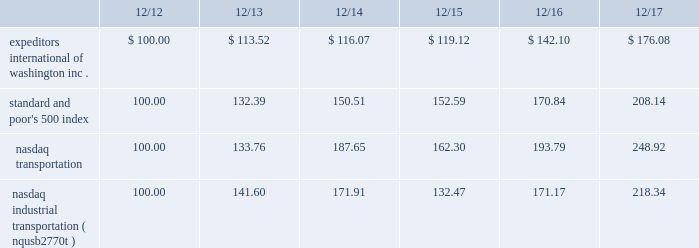The graph below compares expeditors international of washington , inc.'s cumulative 5-year total shareholder return on common stock with the cumulative total returns of the s&p 500 index , the nasdaq transportation index , and the nasdaq industrial transportation index ( nqusb2770t ) as a replacement for the nasdaq transportation index .
The company is making the modification to reference a specific transportation index and to source that data directly from nasdaq .
The graph assumes that the value of the investment in our common stock and in each of the indexes ( including reinvestment of dividends ) was $ 100 on 12/31/2012 and tracks it through 12/31/2017 .
Total return assumes reinvestment of dividends in each of the indices indicated .
Comparison of 5-year cumulative total return among expeditors international of washington , inc. , the s&p 500 index , the nasdaq industrial transportation index and the nasdaq transportation index. .
The stock price performance included in this graph is not necessarily indicative of future stock price performance .
Item 6 2014 selected financial data financial highlights in thousands , except per share data 2017 2016 2015 2014 2013 revenues ..................................................................... .
$ 6920948 6098037 6616632 6564721 6080257 net revenues1 ............................................................... .
$ 2319189 2164036 2187777 1981427 1882853 net earnings attributable to shareholders ..................... .
$ 489345 430807 457223 376888 348526 diluted earnings attributable to shareholders per share $ 2.69 2.36 2.40 1.92 1.68 basic earnings attributable to shareholders per share.. .
$ 2.73 2.38 2.42 1.92 1.69 dividends declared and paid per common share.......... .
$ 0.84 0.80 0.72 0.64 0.60 cash used for dividends ............................................... .
$ 150495 145123 135673 124634 123292 cash used for share repurchases ................................. .
$ 478258 337658 629991 550781 261936 working capital ............................................................. .
$ 1448333 1288648 1115136 1285188 1526673 total assets .................................................................. .
$ 3117008 2790871 2565577 2870626 2996416 shareholders 2019 equity ..................................................... .
$ 1991858 1844638 1691993 1868408 2084783 weighted average diluted shares outstanding .............. .
181666 182704 190223 196768 206895 weighted average basic shares outstanding ................ .
179247 181282 188941 196147 205995 _______________________ 1non-gaap measure calculated as revenues less directly related operating expenses attributable to our principal services .
See management's discussion and analysis for a reconciliation of net revenues to revenues .
Safe harbor for forward-looking statements under private securities litigation reform act of 1995 ; certain cautionary statements this annual report on form 10-k for the fiscal year ended december 31 , 2017 contains 201cforward-looking statements , 201d as defined in section 27a of the securities act of 1933 , as amended , and section 21e of the securities exchange act of 1934 , as amended .
From time to time , expeditors or its representatives have made or may make forward-looking statements , orally or in writing .
Such forward-looking statements may be included in , but not limited to , press releases , presentations , oral statements made with the approval of an authorized executive officer or in various filings made by expeditors with the securities and exchange commission .
Statements including those preceded by , followed by or that include the words or phrases 201cwill likely result 201d , 201care expected to 201d , "would expect" , "would not expect" , 201cwill continue 201d , 201cis anticipated 201d , 201cestimate 201d , 201cproject 201d , "provisional" , "plan" , "believe" , "probable" , "reasonably possible" , "may" , "could" , "should" , "intends" , "foreseeable future" or similar expressions are intended to identify 201cforward-looking statements 201d within the meaning of the private securities litigation reform act of 1995 .
Such statements are qualified in their entirety by reference to and are accompanied by the discussion in item 1a of certain important factors that could cause actual results to differ materially from such forward-looking statements .
The risks included in item 1a are not exhaustive .
Furthermore , reference is also made to other sections of this report , which include additional factors that could adversely impact expeditors' business and financial performance .
Moreover , expeditors operates in a very competitive , complex and rapidly changing global environment .
New risk factors emerge from time to time and it is not possible for management to predict all of such risk factors , nor can it assess the impact of all of such risk factors on expeditors' business or the extent to which any factor , or combination of factors , may cause actual results to differ materially from those contained in any forward-looking statements .
Accordingly , forward-looking statements cannot be relied upon as a guarantee of actual results .
Shareholders should be aware that while expeditors does , from time to time , communicate with securities analysts , it is against expeditors' policy to disclose to such analysts any material non-public information or other confidential commercial information .
Accordingly , shareholders should not assume that expeditors agrees with any statement or report issued by any analyst irrespective of the content of such statement or report .
Furthermore , expeditors has a policy against issuing financial forecasts or projections or confirming the accuracy of forecasts or projections issued by others .
Accordingly , to the extent that reports issued by securities analysts contain any projections , forecasts or opinions , such reports are not the responsibility of expeditors. .
What is the difference in percentage return between expeditors international of washington inc . and the nasdaq transportation for the five years ended 12/17? 
Computations: (((176.08 - 100) / 100) - ((248.92 - 100) / 100))
Answer: -0.7284. The graph below compares expeditors international of washington , inc.'s cumulative 5-year total shareholder return on common stock with the cumulative total returns of the s&p 500 index , the nasdaq transportation index , and the nasdaq industrial transportation index ( nqusb2770t ) as a replacement for the nasdaq transportation index .
The company is making the modification to reference a specific transportation index and to source that data directly from nasdaq .
The graph assumes that the value of the investment in our common stock and in each of the indexes ( including reinvestment of dividends ) was $ 100 on 12/31/2012 and tracks it through 12/31/2017 .
Total return assumes reinvestment of dividends in each of the indices indicated .
Comparison of 5-year cumulative total return among expeditors international of washington , inc. , the s&p 500 index , the nasdaq industrial transportation index and the nasdaq transportation index. .
The stock price performance included in this graph is not necessarily indicative of future stock price performance .
Item 6 2014 selected financial data financial highlights in thousands , except per share data 2017 2016 2015 2014 2013 revenues ..................................................................... .
$ 6920948 6098037 6616632 6564721 6080257 net revenues1 ............................................................... .
$ 2319189 2164036 2187777 1981427 1882853 net earnings attributable to shareholders ..................... .
$ 489345 430807 457223 376888 348526 diluted earnings attributable to shareholders per share $ 2.69 2.36 2.40 1.92 1.68 basic earnings attributable to shareholders per share.. .
$ 2.73 2.38 2.42 1.92 1.69 dividends declared and paid per common share.......... .
$ 0.84 0.80 0.72 0.64 0.60 cash used for dividends ............................................... .
$ 150495 145123 135673 124634 123292 cash used for share repurchases ................................. .
$ 478258 337658 629991 550781 261936 working capital ............................................................. .
$ 1448333 1288648 1115136 1285188 1526673 total assets .................................................................. .
$ 3117008 2790871 2565577 2870626 2996416 shareholders 2019 equity ..................................................... .
$ 1991858 1844638 1691993 1868408 2084783 weighted average diluted shares outstanding .............. .
181666 182704 190223 196768 206895 weighted average basic shares outstanding ................ .
179247 181282 188941 196147 205995 _______________________ 1non-gaap measure calculated as revenues less directly related operating expenses attributable to our principal services .
See management's discussion and analysis for a reconciliation of net revenues to revenues .
Safe harbor for forward-looking statements under private securities litigation reform act of 1995 ; certain cautionary statements this annual report on form 10-k for the fiscal year ended december 31 , 2017 contains 201cforward-looking statements , 201d as defined in section 27a of the securities act of 1933 , as amended , and section 21e of the securities exchange act of 1934 , as amended .
From time to time , expeditors or its representatives have made or may make forward-looking statements , orally or in writing .
Such forward-looking statements may be included in , but not limited to , press releases , presentations , oral statements made with the approval of an authorized executive officer or in various filings made by expeditors with the securities and exchange commission .
Statements including those preceded by , followed by or that include the words or phrases 201cwill likely result 201d , 201care expected to 201d , "would expect" , "would not expect" , 201cwill continue 201d , 201cis anticipated 201d , 201cestimate 201d , 201cproject 201d , "provisional" , "plan" , "believe" , "probable" , "reasonably possible" , "may" , "could" , "should" , "intends" , "foreseeable future" or similar expressions are intended to identify 201cforward-looking statements 201d within the meaning of the private securities litigation reform act of 1995 .
Such statements are qualified in their entirety by reference to and are accompanied by the discussion in item 1a of certain important factors that could cause actual results to differ materially from such forward-looking statements .
The risks included in item 1a are not exhaustive .
Furthermore , reference is also made to other sections of this report , which include additional factors that could adversely impact expeditors' business and financial performance .
Moreover , expeditors operates in a very competitive , complex and rapidly changing global environment .
New risk factors emerge from time to time and it is not possible for management to predict all of such risk factors , nor can it assess the impact of all of such risk factors on expeditors' business or the extent to which any factor , or combination of factors , may cause actual results to differ materially from those contained in any forward-looking statements .
Accordingly , forward-looking statements cannot be relied upon as a guarantee of actual results .
Shareholders should be aware that while expeditors does , from time to time , communicate with securities analysts , it is against expeditors' policy to disclose to such analysts any material non-public information or other confidential commercial information .
Accordingly , shareholders should not assume that expeditors agrees with any statement or report issued by any analyst irrespective of the content of such statement or report .
Furthermore , expeditors has a policy against issuing financial forecasts or projections or confirming the accuracy of forecasts or projections issued by others .
Accordingly , to the extent that reports issued by securities analysts contain any projections , forecasts or opinions , such reports are not the responsibility of expeditors. .
What is the lowest return rate for the initial year of the investment? 
Rationale: it is the minimum value transformed into a percentage .
Computations: (113.52 - 100)
Answer: 13.52. 